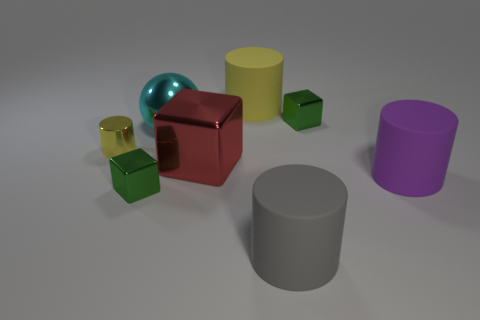Add 2 big red things. How many objects exist? 10 Subtract all balls. How many objects are left? 7 Add 4 blue spheres. How many blue spheres exist? 4 Subtract 2 green blocks. How many objects are left? 6 Subtract all small green shiny cubes. Subtract all large metal balls. How many objects are left? 5 Add 4 large purple matte objects. How many large purple matte objects are left? 5 